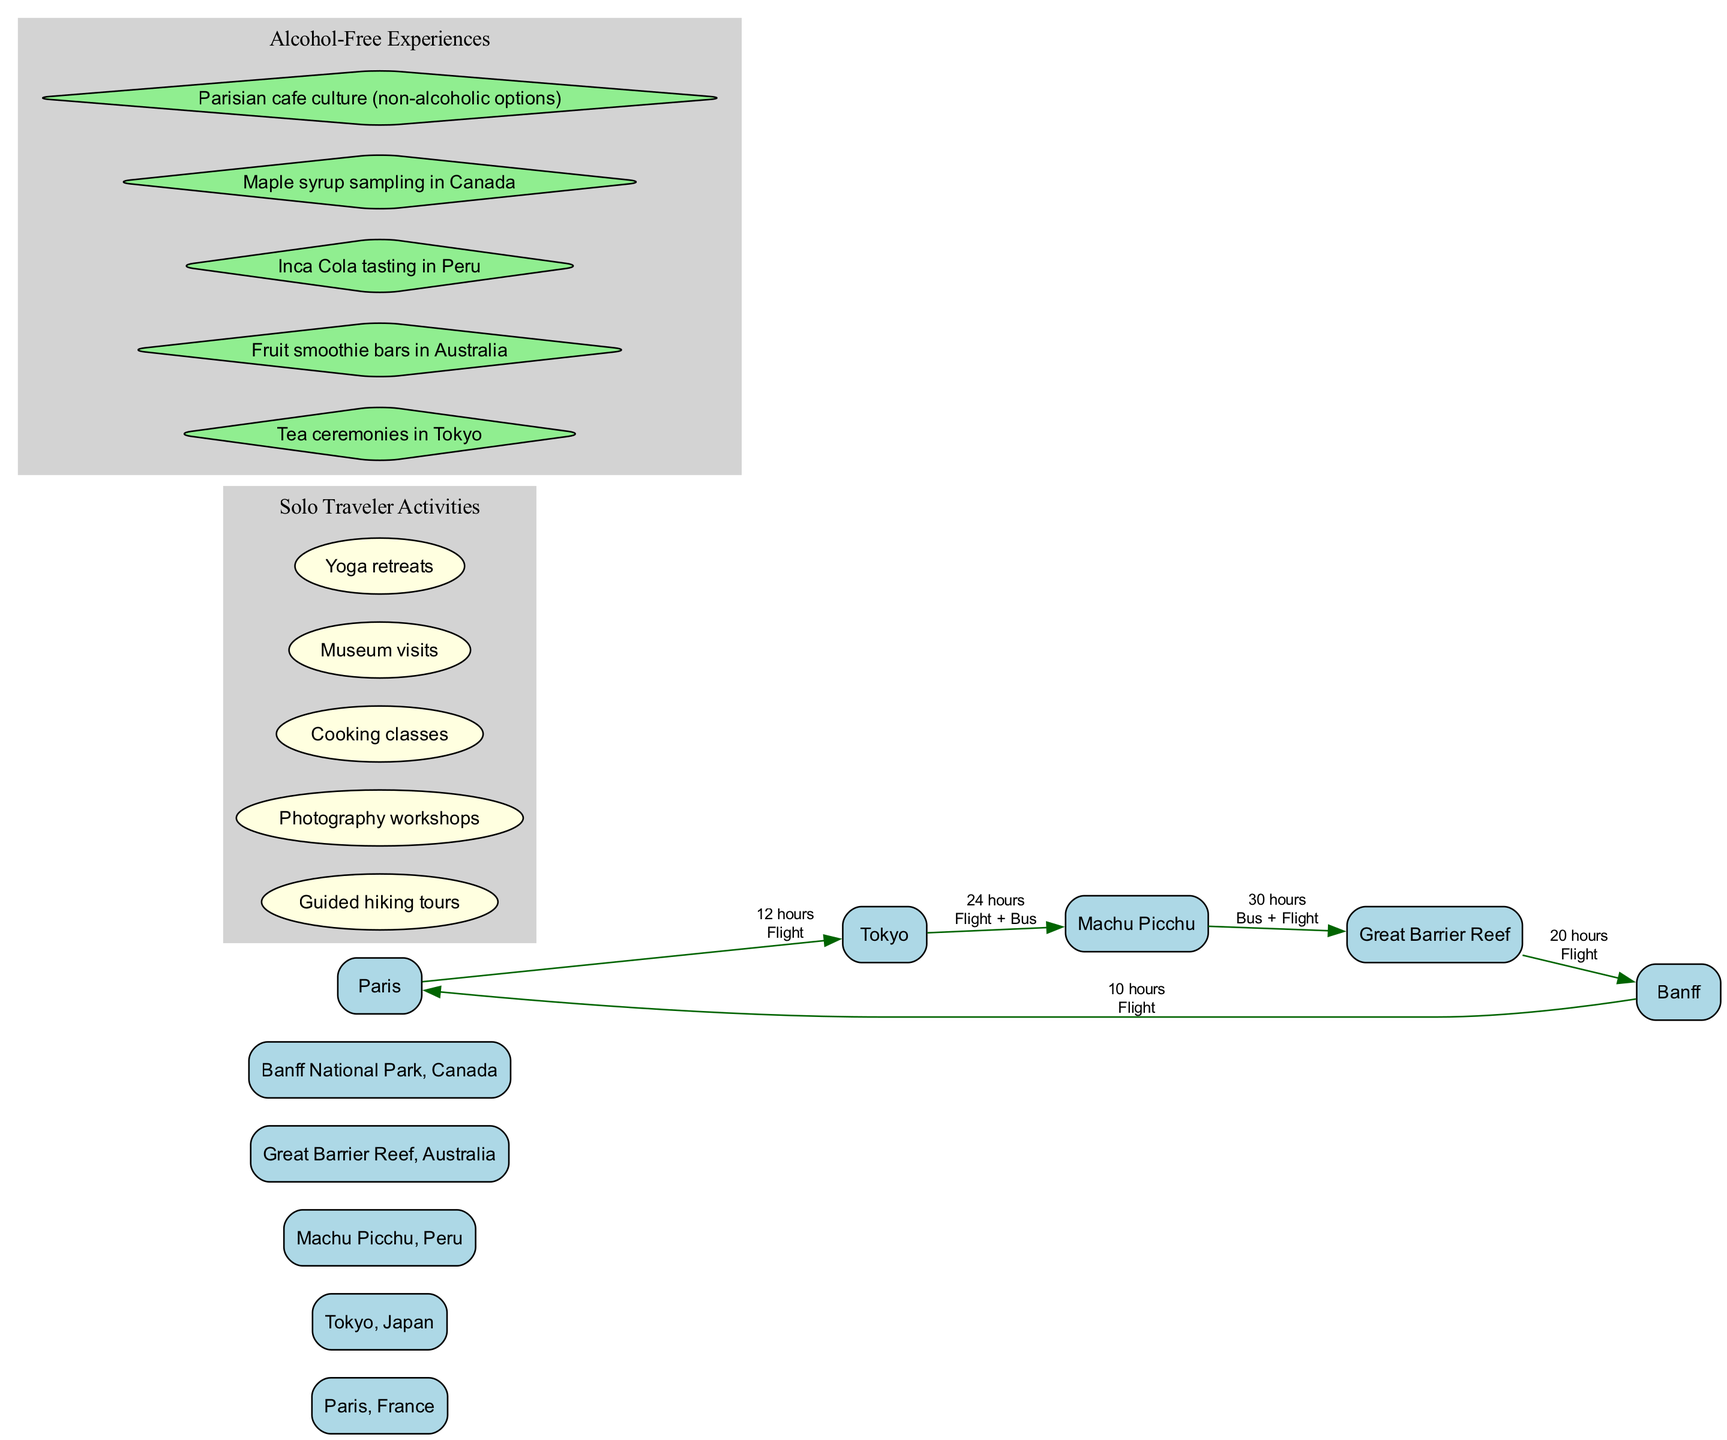What is the travel time from Paris to Tokyo? The travel time from Paris to Tokyo is mentioned directly in the travel times section of the diagram. It states "12 hours (Flight)".
Answer: 12 hours What mode of transportation is used to travel from Tokyo to Machu Picchu? In the travel times section, it specifies that the mode of transportation for traveling from Tokyo to Machu Picchu involves both a flight and a bus. Hence, it states "Flight + Bus".
Answer: Flight + Bus Which destination is connected to the Great Barrier Reef? By examining the edges connected to the Great Barrier Reef, we see it connects to Machu Picchu and Banff. Thus, the destinations that lead into the Great Barrier Reef are both Machu Picchu and Banff.
Answer: Machu Picchu, Banff How many solo traveler activities are listed in the diagram? The number of solo traveler activities can be determined by counting the nodes listed under the "Solo Traveler Activities" cluster in the diagram. There are a total of 5 activities shown.
Answer: 5 What is the shortest travel time mentioned among all routes? To identify the shortest travel time, we compare all the travel times provided. The shortest mentioned is "10 hours (Flight)" for the route from Banff to Paris.
Answer: 10 hours Which alcohol-free experience is associated with Tokyo? Looking at the "Alcohol-Free Experiences" section, the option specifically associated with Tokyo is "Tea ceremonies in Tokyo." This matches the location mentioned.
Answer: Tea ceremonies in Tokyo How many edges connect Machu Picchu to other destinations? By analyzing the connections in the diagram, we see that Machu Picchu has two outgoing edges, one leading to the Great Barrier Reef and the other to Tokyo. Therefore, it connects to two other destinations.
Answer: 2 Which activity involves taking photos? Among the listed solo traveler activities, "Photography workshops" pertains to taking photos. This is explicitly listed in the activities section.
Answer: Photography workshops What is the total travel time from Banff to Paris? Directly checking the travel times in the diagram, it shows that the travel time from Banff to Paris is "10 hours (Flight)". This states the specific route and the associated time.
Answer: 10 hours 